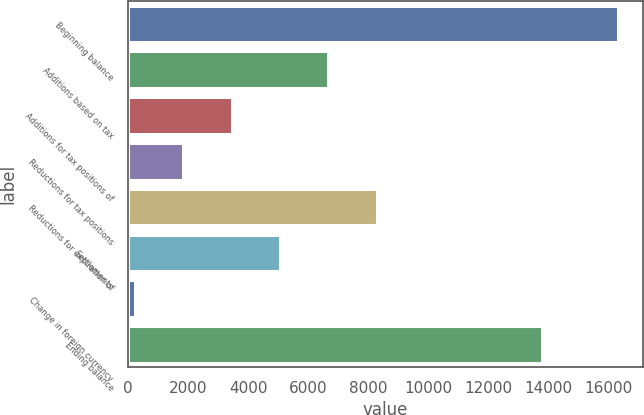<chart> <loc_0><loc_0><loc_500><loc_500><bar_chart><fcel>Beginning balance<fcel>Additions based on tax<fcel>Additions for tax positions of<fcel>Reductions for tax positions<fcel>Reductions for expiration of<fcel>Settlements<fcel>Change in foreign currency<fcel>Ending balance<nl><fcel>16347<fcel>6670.2<fcel>3444.6<fcel>1831.8<fcel>8283<fcel>5057.4<fcel>219<fcel>13804<nl></chart> 